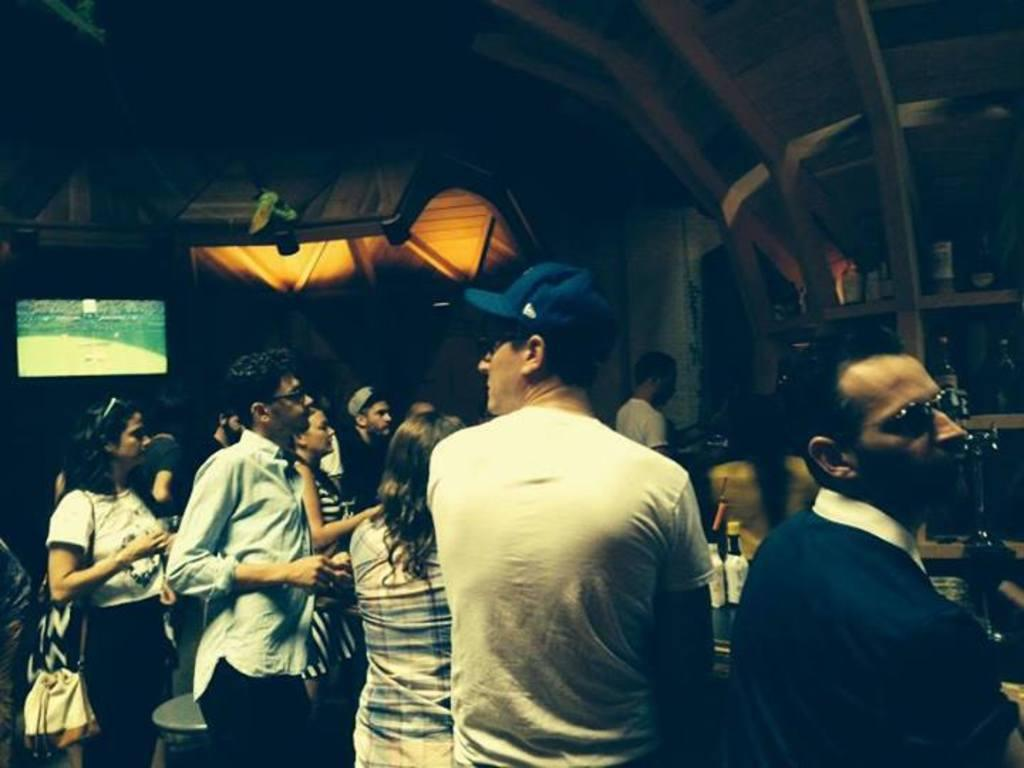Who or what is present in the image? There are people in the image. What can be seen on the shelves in the image? There are shelves with objects in the image. What type of structure is visible in the image? There is a shed visible in the image. What might be used for displaying information or media in the image? There is a screen in the image. What is one of the materials used to construct the wall in the image? There is a wall in the image. What type of container can be seen in the image? There are bottles in the image. What type of coal is being transported by the cart in the image? There is no cart or coal present in the image. How much force is being applied to the objects on the shelves in the image? The amount of force being applied to the objects on the shelves cannot be determined from the image. 